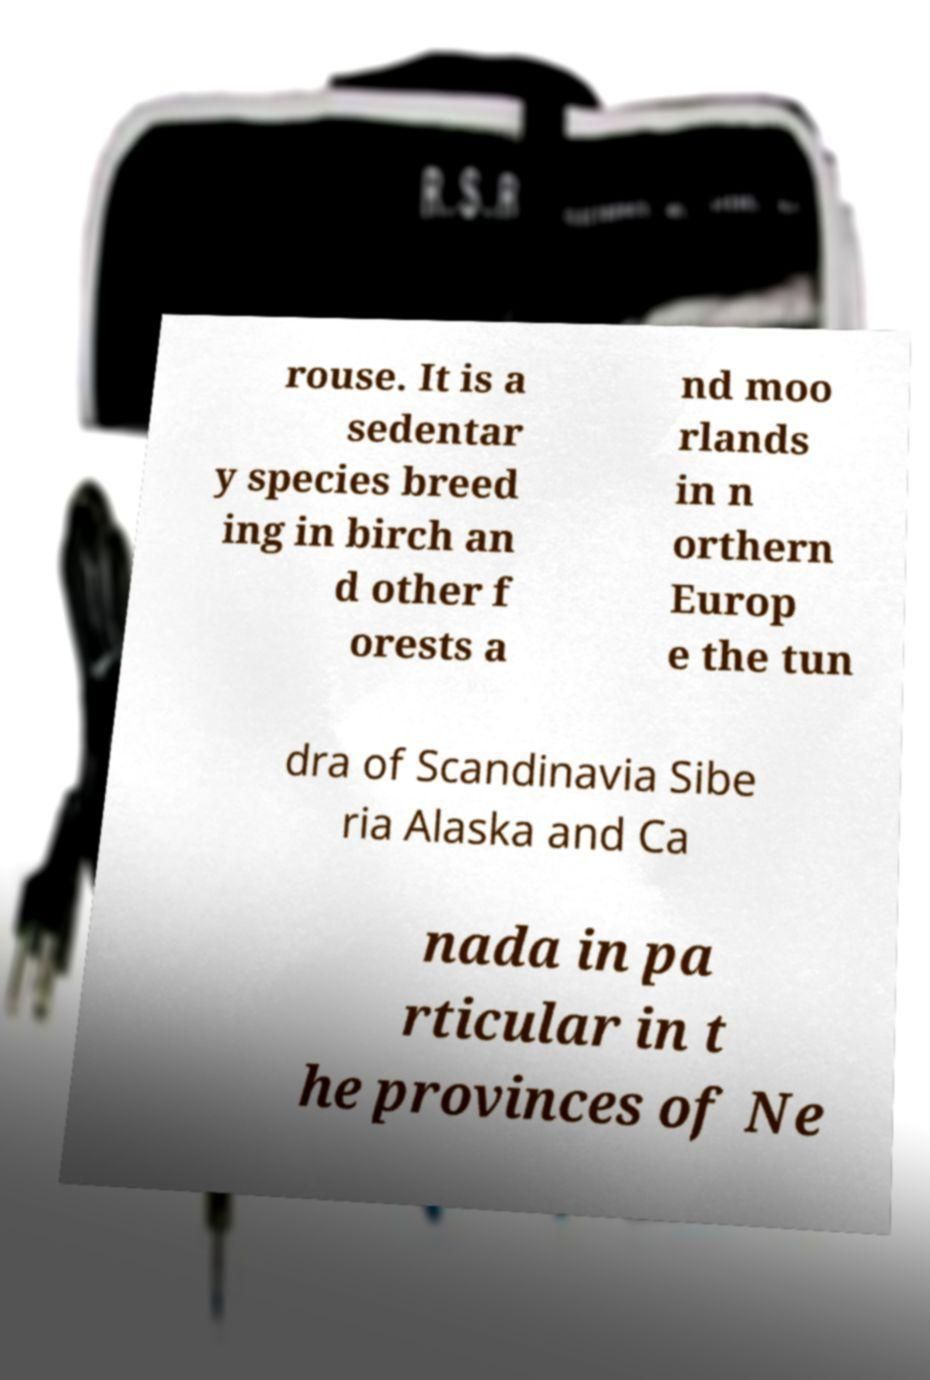I need the written content from this picture converted into text. Can you do that? rouse. It is a sedentar y species breed ing in birch an d other f orests a nd moo rlands in n orthern Europ e the tun dra of Scandinavia Sibe ria Alaska and Ca nada in pa rticular in t he provinces of Ne 